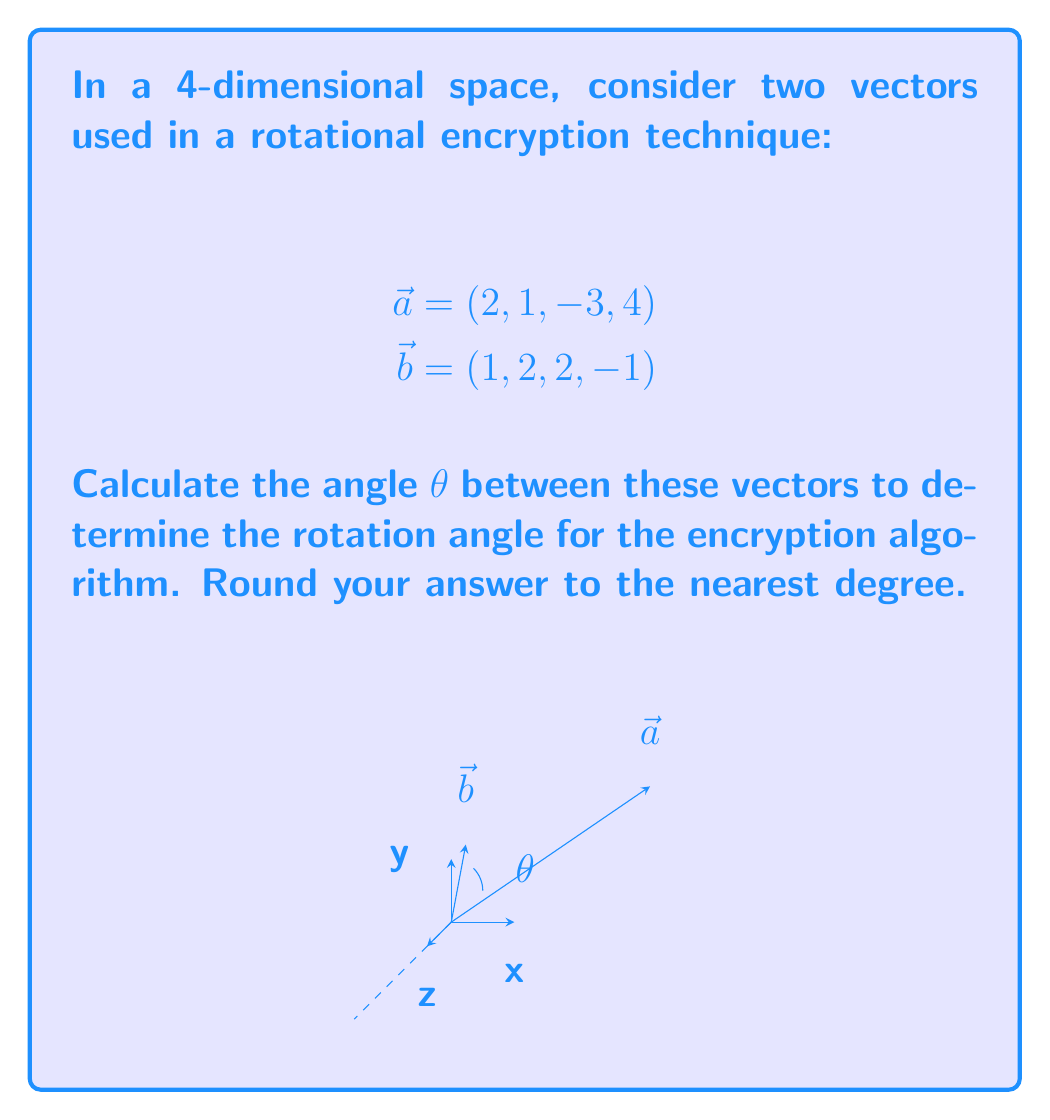Give your solution to this math problem. To find the angle between two vectors in n-dimensional space, we can use the dot product formula:

$$\cos \theta = \frac{\vec{a} \cdot \vec{b}}{|\vec{a}||\vec{b}|}$$

Step 1: Calculate the dot product $\vec{a} \cdot \vec{b}$
$$\vec{a} \cdot \vec{b} = (2)(1) + (1)(2) + (-3)(2) + (4)(-1) = 2 + 2 - 6 - 4 = -6$$

Step 2: Calculate the magnitudes of $\vec{a}$ and $\vec{b}$
$$|\vec{a}| = \sqrt{2^2 + 1^2 + (-3)^2 + 4^2} = \sqrt{4 + 1 + 9 + 16} = \sqrt{30}$$
$$|\vec{b}| = \sqrt{1^2 + 2^2 + 2^2 + (-1)^2} = \sqrt{1 + 4 + 4 + 1} = \sqrt{10}$$

Step 3: Substitute into the formula
$$\cos \theta = \frac{-6}{\sqrt{30}\sqrt{10}}$$

Step 4: Simplify
$$\cos \theta = -\frac{6}{\sqrt{300}} = -\frac{6\sqrt{3}}{30} = -\frac{\sqrt{3}}{5}$$

Step 5: Take the inverse cosine (arccos) of both sides
$$\theta = \arccos(-\frac{\sqrt{3}}{5})$$

Step 6: Calculate and round to the nearest degree
$$\theta \approx 108°$$

This angle can be used as a parameter in the rotational encryption technique to secure user data against surveillance.
Answer: 108° 